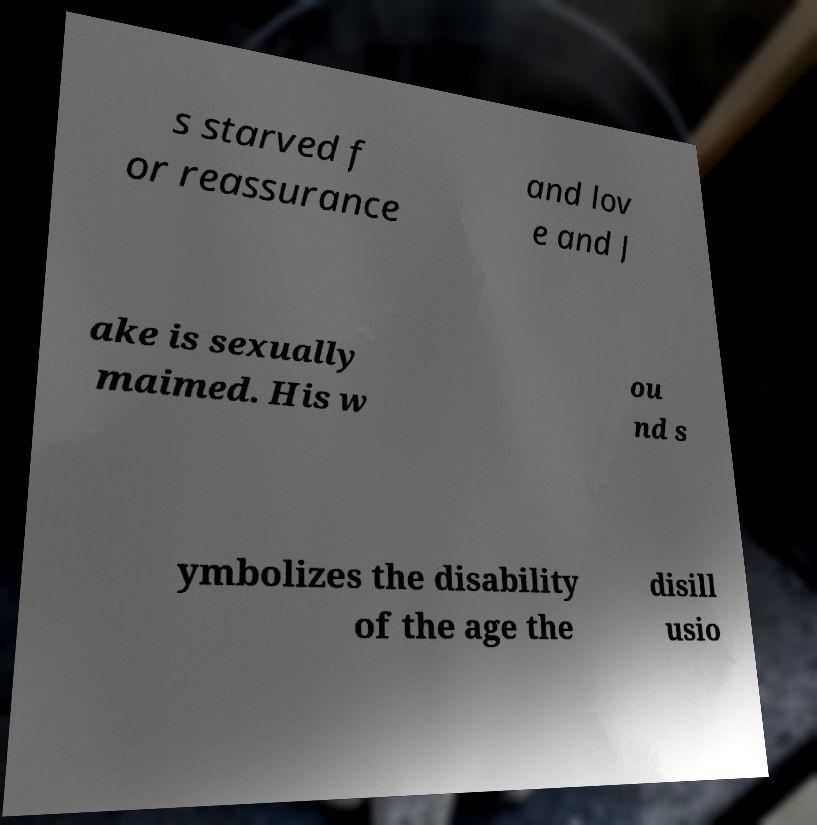Could you extract and type out the text from this image? s starved f or reassurance and lov e and J ake is sexually maimed. His w ou nd s ymbolizes the disability of the age the disill usio 